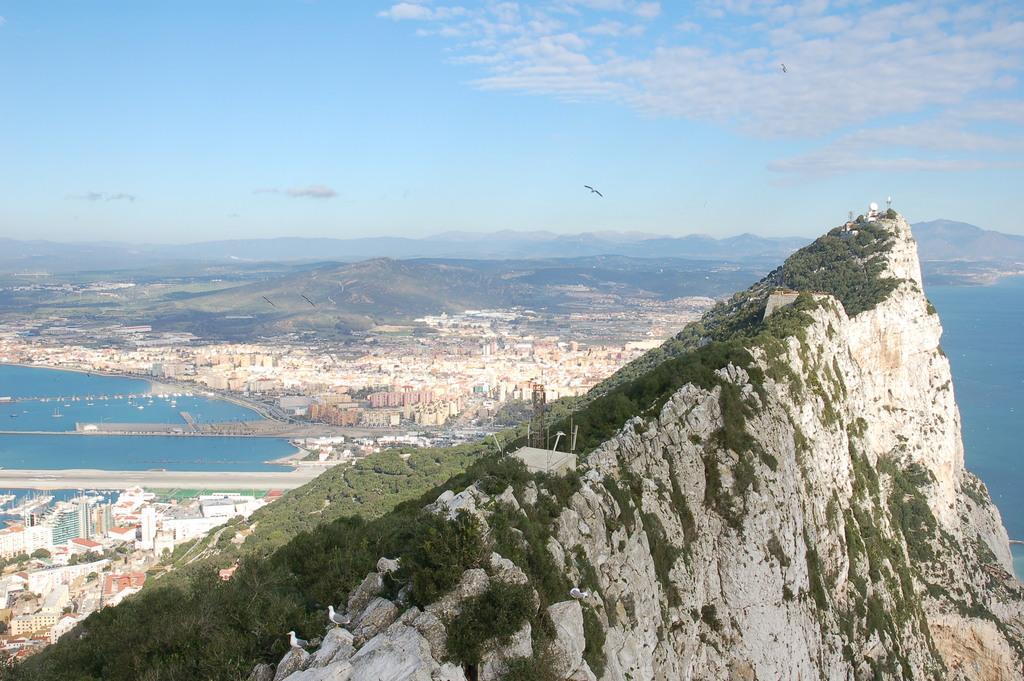Could you give a brief overview of what you see in this image? In this image we can see hills, trees, buildings, river, birds flying in the air and sky with clouds. 